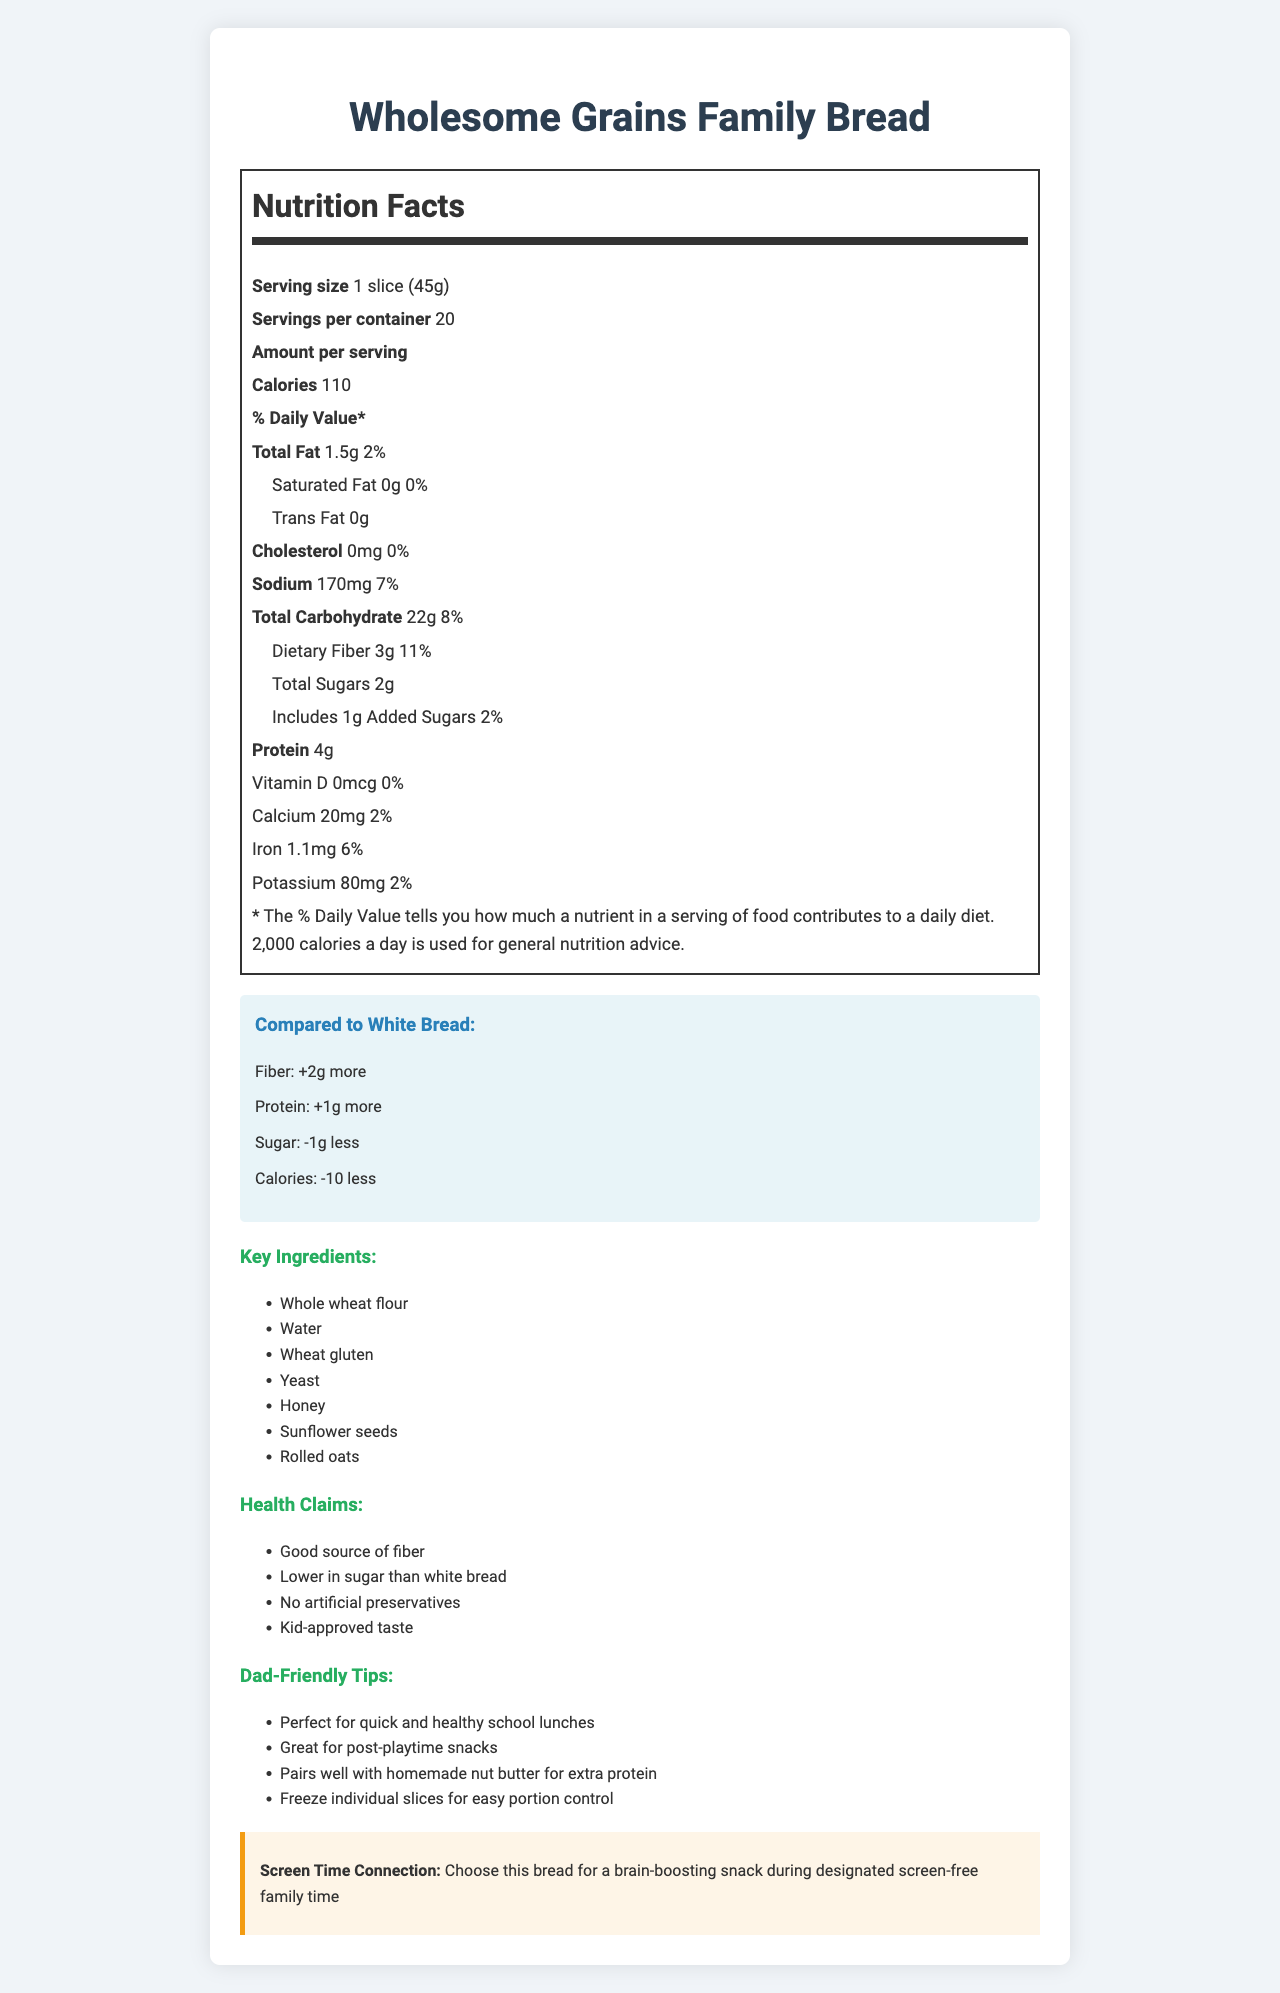what is the serving size for Wholesome Grains Family Bread? The serving size is explicitly mentioned as "1 slice (45g)" in the nutrition label section.
Answer: 1 slice (45g) how many calories are in one serving of Wholesome Grains Family Bread? The document states that there are 110 calories per serving.
Answer: 110 what is the Daily Value percentage of dietary fiber in Wholesome Grains Family Bread? The nutritional label specifies that the Daily Value of dietary fiber is 11%.
Answer: 11% how much protein is in a slice of Wholesome Grains Family Bread? The protein content per serving is listed as 4g.
Answer: 4g what is the amount of sodium in one serving? The sodium content per serving is specifically noted as 170mg.
Answer: 170mg how much dietary fiber does Wholesome Grains Family Bread have compared to white bread? A. Same amount B. 1g more C. 2g more D. None of the above The comparison section states that the fiber difference between Wholesome Grains Family Bread and white bread is "+2g."
Answer: C. 2g more which of the following is NOT a health claim made by Wholesome Grains Family Bread? A. Good source of fiber B. Lower in sodium C. No artificial preservatives D. Kid-approved taste The health claims listed include: "Good source of fiber," "Lower in sugar than white bread," "No artificial preservatives," and "Kid-approved taste," but do not mention "Lower in sodium."
Answer: B. Lower in sodium Is Wholesome Grains Family Bread lower in sugar than white bread? The comparison section notes that Wholesome Grains Family Bread has 1g less sugar than white bread.
Answer: Yes Does Wholesome Grains Family Bread contain any added sugars? The nutritional label indicates that there is 1g of added sugars in Wholesome Grains Family Bread.
Answer: Yes Summarize the main idea of the document. The document details the nutritional content of Wholesome Grains Family Bread, compares it to white bread, lists key ingredients, outlines health claims, and provides tips for family use, emphasizing its suitability for screen-free family time snacks.
Answer: The document provides a detailed nutritional label for Wholesome Grains Family Bread, highlighting its benefits and comparing it to white bread. It mentions key ingredients, health claims, and dad-friendly tips for incorporating the bread into family meals. Additionally, it makes a connection to screen-free family time by suggesting the bread as a brain-boosting snack. Is the amount of Vitamin D in Wholesome Grains Family Bread significant? The nutritional label shows that the amount of Vitamin D is 0mcg, which is 0% of the Daily Value, indicating it is not significant.
Answer: No What is the key ingredient listed that provides added sweetness to Wholesome Grains Family Bread? The key ingredients section includes "Honey," which provides added sweetness to the bread.
Answer: Honey What tips are provided for a stay-at-home dad to make the most out of Wholesome Grains Family Bread? The dad-friendly tips section offers specific suggestions to help a stay-at-home dad effectively use the bread in various scenarios, emphasizing convenience and nutrition.
Answer: The tips include using it for quick and healthy school lunches, post-playtime snacks, pairing with homemade nut butter for extra protein, and freezing individual slices for easy portion control. What is the health claim related to artificial ingredients in Wholesome Grains Family Bread? The health claims section states that the bread contains "No artificial preservatives."
Answer: No artificial preservatives How many servings are there in one container of Wholesome Grains Family Bread? The number of servings per container is specified as 20 in the nutritional label.
Answer: 20 What does the document state about the difference in calorie content between Wholesome Grains Family Bread and white bread? The comparison section mentions a "-10" calorie difference, indicating that whole grain bread has fewer calories.
Answer: Wholesome Grains Family Bread has 10 fewer calories than white bread. Where is the information about the "brain-boosting snack" connection mentioned in the document? The reference to the bread as a "brain-boosting snack" during screen-free family time is found in the screen-time connection section.
Answer: The screen-time connection section What is the potassium content in Wholesome Grains Family Bread? The potassium content per serving is listed as 80mg in the nutritional label.
Answer: 80mg How much iron does Wholesome Grains Family Bread provide? The nutritional label states that each serving provides 1.1mg of iron.
Answer: 1.1mg Does Wholesome Grains Family Bread contain any trans fat? According to the nutritional label, the amount of trans fat is 0g, indicating there is no trans fat in the bread.
Answer: No What are the potential allergens in Wholesome Grains Family Bread based on the ingredient list? Although the ingredient list is provided, it does not specifically highlight potential allergens such as wheat, gluten, or seeds, and the document does not explicitly state allergen information.
Answer: Not enough information 